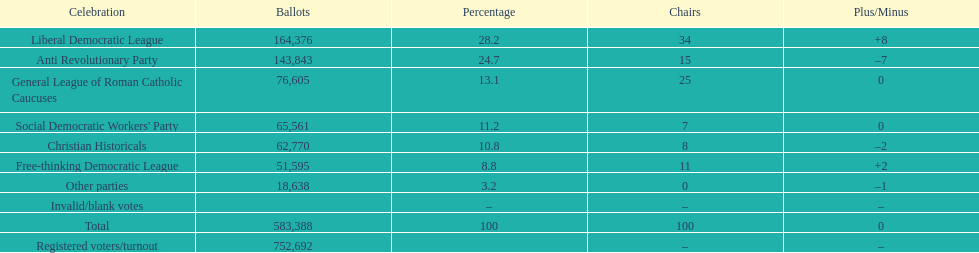What was the difference in the number of votes won by the liberal democratic league compared to the free-thinking democratic league? 112,781. 